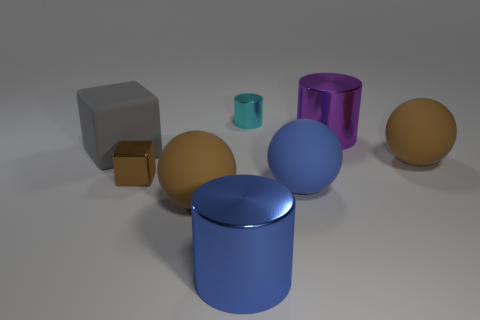Add 2 small yellow matte cubes. How many objects exist? 10 Subtract all balls. How many objects are left? 5 Subtract all big blue metal spheres. Subtract all big metallic cylinders. How many objects are left? 6 Add 4 tiny shiny things. How many tiny shiny things are left? 6 Add 7 big green cylinders. How many big green cylinders exist? 7 Subtract 1 blue cylinders. How many objects are left? 7 